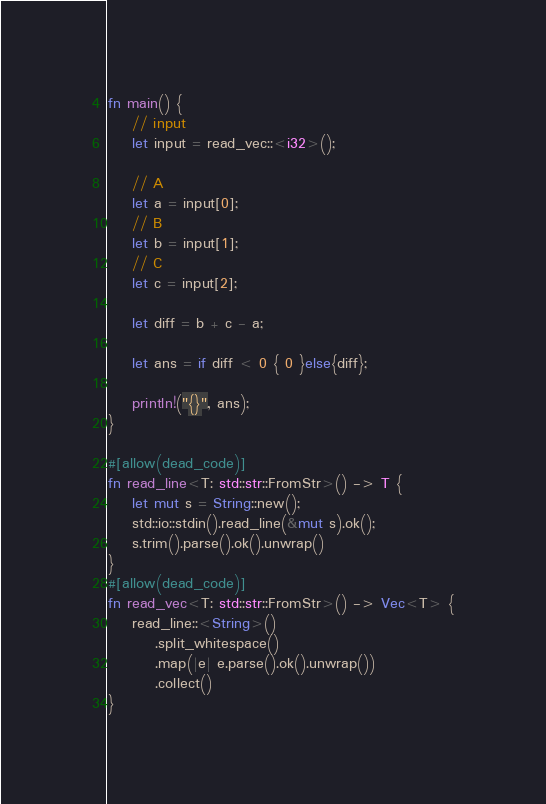<code> <loc_0><loc_0><loc_500><loc_500><_Rust_>
fn main() {
    // input
    let input = read_vec::<i32>();

    // A
    let a = input[0];
    // B
    let b = input[1];
    // C
    let c = input[2];

    let diff = b + c - a;

    let ans = if diff < 0 { 0 }else{diff};

    println!("{}", ans);
}

#[allow(dead_code)]
fn read_line<T: std::str::FromStr>() -> T {
    let mut s = String::new();
    std::io::stdin().read_line(&mut s).ok();
    s.trim().parse().ok().unwrap()
}
#[allow(dead_code)]
fn read_vec<T: std::str::FromStr>() -> Vec<T> {
    read_line::<String>()
        .split_whitespace()
        .map(|e| e.parse().ok().unwrap())
        .collect()
}</code> 